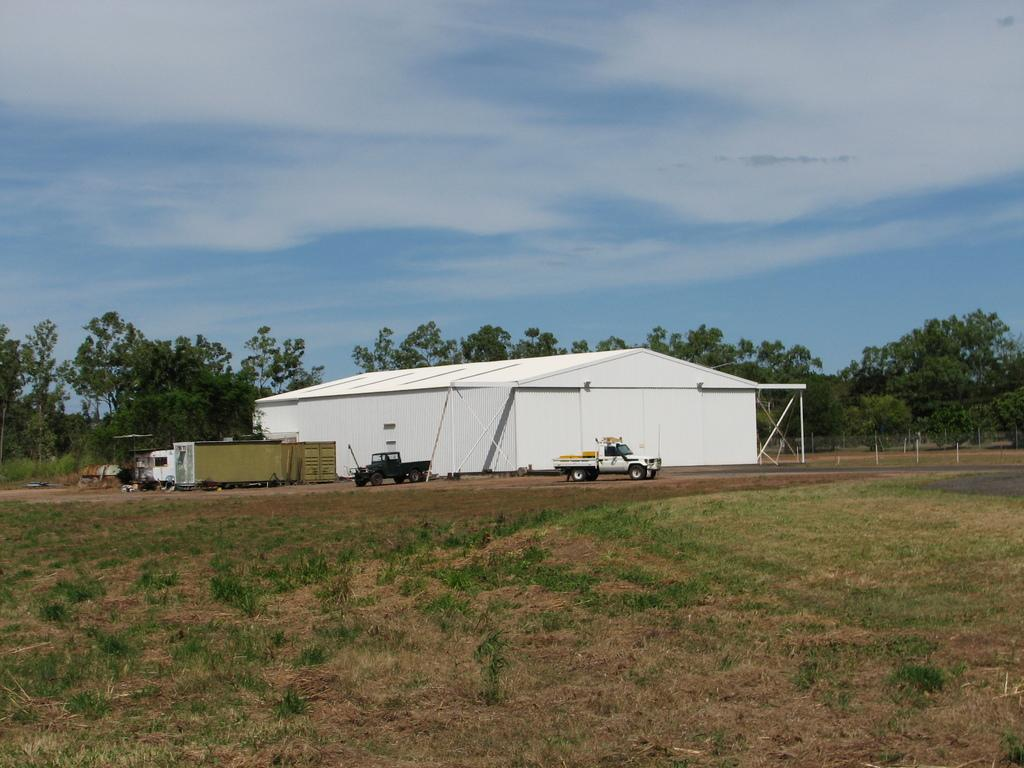What types of objects are on the ground in the image? There are vehicles on the ground in the image. What structure can be seen in the background of the image? There is a shed in the background of the image. What type of vegetation is visible in the background of the image? There are trees in the background of the image. What is visible at the top of the image? The sky is visible at the top of the image. What type of apple is being used as a skate in the image? There is no apple or skate present in the image. What type of food is being served in the image? The provided facts do not mention any food being served in the image. 